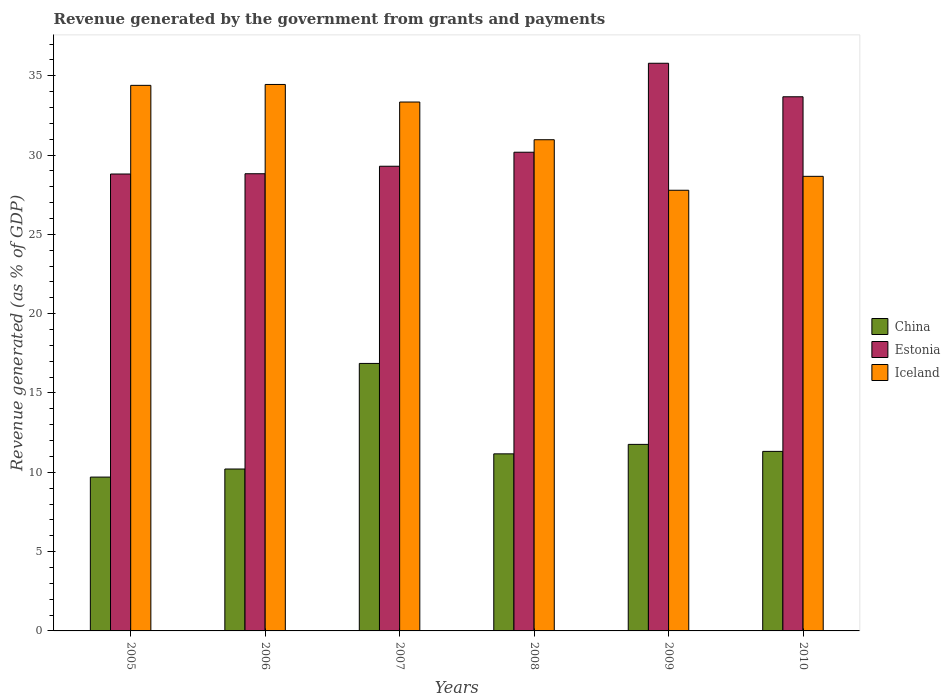How many different coloured bars are there?
Your response must be concise. 3. Are the number of bars on each tick of the X-axis equal?
Your answer should be very brief. Yes. How many bars are there on the 1st tick from the left?
Your answer should be very brief. 3. How many bars are there on the 5th tick from the right?
Offer a very short reply. 3. What is the revenue generated by the government in Iceland in 2010?
Give a very brief answer. 28.66. Across all years, what is the maximum revenue generated by the government in China?
Your answer should be very brief. 16.86. Across all years, what is the minimum revenue generated by the government in China?
Provide a short and direct response. 9.7. In which year was the revenue generated by the government in Estonia minimum?
Provide a succinct answer. 2005. What is the total revenue generated by the government in Iceland in the graph?
Offer a terse response. 189.6. What is the difference between the revenue generated by the government in China in 2006 and that in 2010?
Provide a succinct answer. -1.11. What is the difference between the revenue generated by the government in China in 2009 and the revenue generated by the government in Iceland in 2006?
Your answer should be very brief. -22.69. What is the average revenue generated by the government in Iceland per year?
Give a very brief answer. 31.6. In the year 2007, what is the difference between the revenue generated by the government in Iceland and revenue generated by the government in Estonia?
Give a very brief answer. 4.05. In how many years, is the revenue generated by the government in Estonia greater than 33 %?
Provide a short and direct response. 2. What is the ratio of the revenue generated by the government in Estonia in 2006 to that in 2009?
Offer a very short reply. 0.81. Is the revenue generated by the government in China in 2005 less than that in 2008?
Your answer should be very brief. Yes. What is the difference between the highest and the second highest revenue generated by the government in Iceland?
Your answer should be compact. 0.06. What is the difference between the highest and the lowest revenue generated by the government in China?
Offer a terse response. 7.17. Is the sum of the revenue generated by the government in Iceland in 2005 and 2009 greater than the maximum revenue generated by the government in China across all years?
Provide a short and direct response. Yes. What does the 2nd bar from the left in 2007 represents?
Your answer should be very brief. Estonia. What does the 2nd bar from the right in 2005 represents?
Make the answer very short. Estonia. How many bars are there?
Provide a succinct answer. 18. Are all the bars in the graph horizontal?
Make the answer very short. No. Where does the legend appear in the graph?
Your response must be concise. Center right. How are the legend labels stacked?
Provide a succinct answer. Vertical. What is the title of the graph?
Your answer should be compact. Revenue generated by the government from grants and payments. Does "Tuvalu" appear as one of the legend labels in the graph?
Provide a succinct answer. No. What is the label or title of the Y-axis?
Your answer should be very brief. Revenue generated (as % of GDP). What is the Revenue generated (as % of GDP) in China in 2005?
Your answer should be very brief. 9.7. What is the Revenue generated (as % of GDP) in Estonia in 2005?
Your answer should be very brief. 28.81. What is the Revenue generated (as % of GDP) in Iceland in 2005?
Make the answer very short. 34.4. What is the Revenue generated (as % of GDP) of China in 2006?
Offer a terse response. 10.21. What is the Revenue generated (as % of GDP) in Estonia in 2006?
Ensure brevity in your answer.  28.82. What is the Revenue generated (as % of GDP) in Iceland in 2006?
Ensure brevity in your answer.  34.45. What is the Revenue generated (as % of GDP) of China in 2007?
Your answer should be compact. 16.86. What is the Revenue generated (as % of GDP) of Estonia in 2007?
Offer a very short reply. 29.3. What is the Revenue generated (as % of GDP) in Iceland in 2007?
Your answer should be very brief. 33.34. What is the Revenue generated (as % of GDP) in China in 2008?
Your response must be concise. 11.16. What is the Revenue generated (as % of GDP) in Estonia in 2008?
Give a very brief answer. 30.18. What is the Revenue generated (as % of GDP) of Iceland in 2008?
Offer a terse response. 30.97. What is the Revenue generated (as % of GDP) in China in 2009?
Offer a very short reply. 11.76. What is the Revenue generated (as % of GDP) of Estonia in 2009?
Provide a short and direct response. 35.79. What is the Revenue generated (as % of GDP) of Iceland in 2009?
Provide a succinct answer. 27.78. What is the Revenue generated (as % of GDP) in China in 2010?
Your response must be concise. 11.32. What is the Revenue generated (as % of GDP) of Estonia in 2010?
Your answer should be compact. 33.68. What is the Revenue generated (as % of GDP) of Iceland in 2010?
Ensure brevity in your answer.  28.66. Across all years, what is the maximum Revenue generated (as % of GDP) in China?
Give a very brief answer. 16.86. Across all years, what is the maximum Revenue generated (as % of GDP) of Estonia?
Provide a short and direct response. 35.79. Across all years, what is the maximum Revenue generated (as % of GDP) of Iceland?
Keep it short and to the point. 34.45. Across all years, what is the minimum Revenue generated (as % of GDP) in China?
Provide a short and direct response. 9.7. Across all years, what is the minimum Revenue generated (as % of GDP) of Estonia?
Your answer should be very brief. 28.81. Across all years, what is the minimum Revenue generated (as % of GDP) in Iceland?
Your response must be concise. 27.78. What is the total Revenue generated (as % of GDP) of China in the graph?
Provide a succinct answer. 71.01. What is the total Revenue generated (as % of GDP) of Estonia in the graph?
Your answer should be very brief. 186.57. What is the total Revenue generated (as % of GDP) of Iceland in the graph?
Make the answer very short. 189.6. What is the difference between the Revenue generated (as % of GDP) in China in 2005 and that in 2006?
Make the answer very short. -0.51. What is the difference between the Revenue generated (as % of GDP) of Estonia in 2005 and that in 2006?
Ensure brevity in your answer.  -0.02. What is the difference between the Revenue generated (as % of GDP) of Iceland in 2005 and that in 2006?
Your response must be concise. -0.06. What is the difference between the Revenue generated (as % of GDP) in China in 2005 and that in 2007?
Offer a terse response. -7.17. What is the difference between the Revenue generated (as % of GDP) of Estonia in 2005 and that in 2007?
Your answer should be very brief. -0.49. What is the difference between the Revenue generated (as % of GDP) in Iceland in 2005 and that in 2007?
Give a very brief answer. 1.05. What is the difference between the Revenue generated (as % of GDP) of China in 2005 and that in 2008?
Ensure brevity in your answer.  -1.47. What is the difference between the Revenue generated (as % of GDP) of Estonia in 2005 and that in 2008?
Provide a short and direct response. -1.37. What is the difference between the Revenue generated (as % of GDP) in Iceland in 2005 and that in 2008?
Provide a succinct answer. 3.43. What is the difference between the Revenue generated (as % of GDP) in China in 2005 and that in 2009?
Make the answer very short. -2.06. What is the difference between the Revenue generated (as % of GDP) of Estonia in 2005 and that in 2009?
Give a very brief answer. -6.98. What is the difference between the Revenue generated (as % of GDP) of Iceland in 2005 and that in 2009?
Give a very brief answer. 6.61. What is the difference between the Revenue generated (as % of GDP) in China in 2005 and that in 2010?
Offer a very short reply. -1.62. What is the difference between the Revenue generated (as % of GDP) of Estonia in 2005 and that in 2010?
Your answer should be compact. -4.87. What is the difference between the Revenue generated (as % of GDP) in Iceland in 2005 and that in 2010?
Make the answer very short. 5.74. What is the difference between the Revenue generated (as % of GDP) of China in 2006 and that in 2007?
Provide a succinct answer. -6.66. What is the difference between the Revenue generated (as % of GDP) in Estonia in 2006 and that in 2007?
Ensure brevity in your answer.  -0.47. What is the difference between the Revenue generated (as % of GDP) of Iceland in 2006 and that in 2007?
Your response must be concise. 1.11. What is the difference between the Revenue generated (as % of GDP) in China in 2006 and that in 2008?
Provide a succinct answer. -0.96. What is the difference between the Revenue generated (as % of GDP) in Estonia in 2006 and that in 2008?
Your answer should be very brief. -1.36. What is the difference between the Revenue generated (as % of GDP) of Iceland in 2006 and that in 2008?
Provide a succinct answer. 3.48. What is the difference between the Revenue generated (as % of GDP) of China in 2006 and that in 2009?
Your answer should be compact. -1.55. What is the difference between the Revenue generated (as % of GDP) of Estonia in 2006 and that in 2009?
Provide a succinct answer. -6.97. What is the difference between the Revenue generated (as % of GDP) in Iceland in 2006 and that in 2009?
Give a very brief answer. 6.67. What is the difference between the Revenue generated (as % of GDP) in China in 2006 and that in 2010?
Make the answer very short. -1.11. What is the difference between the Revenue generated (as % of GDP) of Estonia in 2006 and that in 2010?
Give a very brief answer. -4.85. What is the difference between the Revenue generated (as % of GDP) of Iceland in 2006 and that in 2010?
Provide a short and direct response. 5.79. What is the difference between the Revenue generated (as % of GDP) in China in 2007 and that in 2008?
Offer a very short reply. 5.7. What is the difference between the Revenue generated (as % of GDP) in Estonia in 2007 and that in 2008?
Provide a short and direct response. -0.88. What is the difference between the Revenue generated (as % of GDP) of Iceland in 2007 and that in 2008?
Your answer should be compact. 2.38. What is the difference between the Revenue generated (as % of GDP) in China in 2007 and that in 2009?
Your response must be concise. 5.1. What is the difference between the Revenue generated (as % of GDP) of Estonia in 2007 and that in 2009?
Provide a succinct answer. -6.49. What is the difference between the Revenue generated (as % of GDP) in Iceland in 2007 and that in 2009?
Your answer should be very brief. 5.56. What is the difference between the Revenue generated (as % of GDP) in China in 2007 and that in 2010?
Offer a terse response. 5.54. What is the difference between the Revenue generated (as % of GDP) in Estonia in 2007 and that in 2010?
Your answer should be very brief. -4.38. What is the difference between the Revenue generated (as % of GDP) in Iceland in 2007 and that in 2010?
Ensure brevity in your answer.  4.69. What is the difference between the Revenue generated (as % of GDP) of China in 2008 and that in 2009?
Ensure brevity in your answer.  -0.6. What is the difference between the Revenue generated (as % of GDP) in Estonia in 2008 and that in 2009?
Offer a very short reply. -5.61. What is the difference between the Revenue generated (as % of GDP) in Iceland in 2008 and that in 2009?
Provide a succinct answer. 3.19. What is the difference between the Revenue generated (as % of GDP) of China in 2008 and that in 2010?
Your answer should be very brief. -0.16. What is the difference between the Revenue generated (as % of GDP) in Estonia in 2008 and that in 2010?
Ensure brevity in your answer.  -3.5. What is the difference between the Revenue generated (as % of GDP) of Iceland in 2008 and that in 2010?
Make the answer very short. 2.31. What is the difference between the Revenue generated (as % of GDP) in China in 2009 and that in 2010?
Make the answer very short. 0.44. What is the difference between the Revenue generated (as % of GDP) of Estonia in 2009 and that in 2010?
Offer a very short reply. 2.11. What is the difference between the Revenue generated (as % of GDP) of Iceland in 2009 and that in 2010?
Provide a succinct answer. -0.88. What is the difference between the Revenue generated (as % of GDP) in China in 2005 and the Revenue generated (as % of GDP) in Estonia in 2006?
Make the answer very short. -19.12. What is the difference between the Revenue generated (as % of GDP) of China in 2005 and the Revenue generated (as % of GDP) of Iceland in 2006?
Provide a short and direct response. -24.75. What is the difference between the Revenue generated (as % of GDP) of Estonia in 2005 and the Revenue generated (as % of GDP) of Iceland in 2006?
Your answer should be very brief. -5.65. What is the difference between the Revenue generated (as % of GDP) of China in 2005 and the Revenue generated (as % of GDP) of Estonia in 2007?
Your answer should be compact. -19.6. What is the difference between the Revenue generated (as % of GDP) of China in 2005 and the Revenue generated (as % of GDP) of Iceland in 2007?
Provide a short and direct response. -23.65. What is the difference between the Revenue generated (as % of GDP) of Estonia in 2005 and the Revenue generated (as % of GDP) of Iceland in 2007?
Offer a terse response. -4.54. What is the difference between the Revenue generated (as % of GDP) of China in 2005 and the Revenue generated (as % of GDP) of Estonia in 2008?
Offer a very short reply. -20.48. What is the difference between the Revenue generated (as % of GDP) of China in 2005 and the Revenue generated (as % of GDP) of Iceland in 2008?
Your response must be concise. -21.27. What is the difference between the Revenue generated (as % of GDP) of Estonia in 2005 and the Revenue generated (as % of GDP) of Iceland in 2008?
Give a very brief answer. -2.16. What is the difference between the Revenue generated (as % of GDP) of China in 2005 and the Revenue generated (as % of GDP) of Estonia in 2009?
Your answer should be compact. -26.09. What is the difference between the Revenue generated (as % of GDP) of China in 2005 and the Revenue generated (as % of GDP) of Iceland in 2009?
Keep it short and to the point. -18.08. What is the difference between the Revenue generated (as % of GDP) of Estonia in 2005 and the Revenue generated (as % of GDP) of Iceland in 2009?
Offer a very short reply. 1.02. What is the difference between the Revenue generated (as % of GDP) of China in 2005 and the Revenue generated (as % of GDP) of Estonia in 2010?
Offer a terse response. -23.98. What is the difference between the Revenue generated (as % of GDP) of China in 2005 and the Revenue generated (as % of GDP) of Iceland in 2010?
Ensure brevity in your answer.  -18.96. What is the difference between the Revenue generated (as % of GDP) in Estonia in 2005 and the Revenue generated (as % of GDP) in Iceland in 2010?
Make the answer very short. 0.15. What is the difference between the Revenue generated (as % of GDP) of China in 2006 and the Revenue generated (as % of GDP) of Estonia in 2007?
Ensure brevity in your answer.  -19.09. What is the difference between the Revenue generated (as % of GDP) of China in 2006 and the Revenue generated (as % of GDP) of Iceland in 2007?
Ensure brevity in your answer.  -23.14. What is the difference between the Revenue generated (as % of GDP) in Estonia in 2006 and the Revenue generated (as % of GDP) in Iceland in 2007?
Make the answer very short. -4.52. What is the difference between the Revenue generated (as % of GDP) of China in 2006 and the Revenue generated (as % of GDP) of Estonia in 2008?
Offer a terse response. -19.97. What is the difference between the Revenue generated (as % of GDP) in China in 2006 and the Revenue generated (as % of GDP) in Iceland in 2008?
Provide a short and direct response. -20.76. What is the difference between the Revenue generated (as % of GDP) of Estonia in 2006 and the Revenue generated (as % of GDP) of Iceland in 2008?
Your response must be concise. -2.14. What is the difference between the Revenue generated (as % of GDP) in China in 2006 and the Revenue generated (as % of GDP) in Estonia in 2009?
Provide a succinct answer. -25.58. What is the difference between the Revenue generated (as % of GDP) in China in 2006 and the Revenue generated (as % of GDP) in Iceland in 2009?
Your answer should be very brief. -17.57. What is the difference between the Revenue generated (as % of GDP) in Estonia in 2006 and the Revenue generated (as % of GDP) in Iceland in 2009?
Offer a very short reply. 1.04. What is the difference between the Revenue generated (as % of GDP) in China in 2006 and the Revenue generated (as % of GDP) in Estonia in 2010?
Your response must be concise. -23.47. What is the difference between the Revenue generated (as % of GDP) in China in 2006 and the Revenue generated (as % of GDP) in Iceland in 2010?
Provide a short and direct response. -18.45. What is the difference between the Revenue generated (as % of GDP) of Estonia in 2006 and the Revenue generated (as % of GDP) of Iceland in 2010?
Your response must be concise. 0.16. What is the difference between the Revenue generated (as % of GDP) in China in 2007 and the Revenue generated (as % of GDP) in Estonia in 2008?
Ensure brevity in your answer.  -13.32. What is the difference between the Revenue generated (as % of GDP) in China in 2007 and the Revenue generated (as % of GDP) in Iceland in 2008?
Your answer should be compact. -14.1. What is the difference between the Revenue generated (as % of GDP) of Estonia in 2007 and the Revenue generated (as % of GDP) of Iceland in 2008?
Provide a short and direct response. -1.67. What is the difference between the Revenue generated (as % of GDP) of China in 2007 and the Revenue generated (as % of GDP) of Estonia in 2009?
Offer a terse response. -18.92. What is the difference between the Revenue generated (as % of GDP) in China in 2007 and the Revenue generated (as % of GDP) in Iceland in 2009?
Offer a very short reply. -10.92. What is the difference between the Revenue generated (as % of GDP) in Estonia in 2007 and the Revenue generated (as % of GDP) in Iceland in 2009?
Make the answer very short. 1.51. What is the difference between the Revenue generated (as % of GDP) in China in 2007 and the Revenue generated (as % of GDP) in Estonia in 2010?
Offer a terse response. -16.81. What is the difference between the Revenue generated (as % of GDP) of China in 2007 and the Revenue generated (as % of GDP) of Iceland in 2010?
Offer a very short reply. -11.8. What is the difference between the Revenue generated (as % of GDP) in Estonia in 2007 and the Revenue generated (as % of GDP) in Iceland in 2010?
Keep it short and to the point. 0.64. What is the difference between the Revenue generated (as % of GDP) of China in 2008 and the Revenue generated (as % of GDP) of Estonia in 2009?
Your answer should be very brief. -24.62. What is the difference between the Revenue generated (as % of GDP) of China in 2008 and the Revenue generated (as % of GDP) of Iceland in 2009?
Your answer should be very brief. -16.62. What is the difference between the Revenue generated (as % of GDP) in Estonia in 2008 and the Revenue generated (as % of GDP) in Iceland in 2009?
Your answer should be very brief. 2.4. What is the difference between the Revenue generated (as % of GDP) of China in 2008 and the Revenue generated (as % of GDP) of Estonia in 2010?
Provide a succinct answer. -22.51. What is the difference between the Revenue generated (as % of GDP) of China in 2008 and the Revenue generated (as % of GDP) of Iceland in 2010?
Provide a succinct answer. -17.5. What is the difference between the Revenue generated (as % of GDP) of Estonia in 2008 and the Revenue generated (as % of GDP) of Iceland in 2010?
Your response must be concise. 1.52. What is the difference between the Revenue generated (as % of GDP) in China in 2009 and the Revenue generated (as % of GDP) in Estonia in 2010?
Give a very brief answer. -21.92. What is the difference between the Revenue generated (as % of GDP) of China in 2009 and the Revenue generated (as % of GDP) of Iceland in 2010?
Ensure brevity in your answer.  -16.9. What is the difference between the Revenue generated (as % of GDP) of Estonia in 2009 and the Revenue generated (as % of GDP) of Iceland in 2010?
Offer a very short reply. 7.13. What is the average Revenue generated (as % of GDP) of China per year?
Your answer should be compact. 11.84. What is the average Revenue generated (as % of GDP) of Estonia per year?
Make the answer very short. 31.09. What is the average Revenue generated (as % of GDP) of Iceland per year?
Provide a short and direct response. 31.6. In the year 2005, what is the difference between the Revenue generated (as % of GDP) of China and Revenue generated (as % of GDP) of Estonia?
Provide a succinct answer. -19.11. In the year 2005, what is the difference between the Revenue generated (as % of GDP) of China and Revenue generated (as % of GDP) of Iceland?
Make the answer very short. -24.7. In the year 2005, what is the difference between the Revenue generated (as % of GDP) of Estonia and Revenue generated (as % of GDP) of Iceland?
Your response must be concise. -5.59. In the year 2006, what is the difference between the Revenue generated (as % of GDP) in China and Revenue generated (as % of GDP) in Estonia?
Your answer should be compact. -18.62. In the year 2006, what is the difference between the Revenue generated (as % of GDP) of China and Revenue generated (as % of GDP) of Iceland?
Your response must be concise. -24.24. In the year 2006, what is the difference between the Revenue generated (as % of GDP) in Estonia and Revenue generated (as % of GDP) in Iceland?
Offer a very short reply. -5.63. In the year 2007, what is the difference between the Revenue generated (as % of GDP) of China and Revenue generated (as % of GDP) of Estonia?
Provide a short and direct response. -12.43. In the year 2007, what is the difference between the Revenue generated (as % of GDP) in China and Revenue generated (as % of GDP) in Iceland?
Your answer should be very brief. -16.48. In the year 2007, what is the difference between the Revenue generated (as % of GDP) of Estonia and Revenue generated (as % of GDP) of Iceland?
Your answer should be compact. -4.05. In the year 2008, what is the difference between the Revenue generated (as % of GDP) of China and Revenue generated (as % of GDP) of Estonia?
Keep it short and to the point. -19.02. In the year 2008, what is the difference between the Revenue generated (as % of GDP) in China and Revenue generated (as % of GDP) in Iceland?
Offer a very short reply. -19.8. In the year 2008, what is the difference between the Revenue generated (as % of GDP) in Estonia and Revenue generated (as % of GDP) in Iceland?
Give a very brief answer. -0.79. In the year 2009, what is the difference between the Revenue generated (as % of GDP) of China and Revenue generated (as % of GDP) of Estonia?
Give a very brief answer. -24.03. In the year 2009, what is the difference between the Revenue generated (as % of GDP) of China and Revenue generated (as % of GDP) of Iceland?
Give a very brief answer. -16.02. In the year 2009, what is the difference between the Revenue generated (as % of GDP) in Estonia and Revenue generated (as % of GDP) in Iceland?
Offer a terse response. 8.01. In the year 2010, what is the difference between the Revenue generated (as % of GDP) of China and Revenue generated (as % of GDP) of Estonia?
Ensure brevity in your answer.  -22.36. In the year 2010, what is the difference between the Revenue generated (as % of GDP) of China and Revenue generated (as % of GDP) of Iceland?
Provide a succinct answer. -17.34. In the year 2010, what is the difference between the Revenue generated (as % of GDP) of Estonia and Revenue generated (as % of GDP) of Iceland?
Your response must be concise. 5.02. What is the ratio of the Revenue generated (as % of GDP) in China in 2005 to that in 2006?
Give a very brief answer. 0.95. What is the ratio of the Revenue generated (as % of GDP) of China in 2005 to that in 2007?
Provide a succinct answer. 0.58. What is the ratio of the Revenue generated (as % of GDP) of Estonia in 2005 to that in 2007?
Ensure brevity in your answer.  0.98. What is the ratio of the Revenue generated (as % of GDP) in Iceland in 2005 to that in 2007?
Provide a succinct answer. 1.03. What is the ratio of the Revenue generated (as % of GDP) of China in 2005 to that in 2008?
Provide a short and direct response. 0.87. What is the ratio of the Revenue generated (as % of GDP) of Estonia in 2005 to that in 2008?
Offer a very short reply. 0.95. What is the ratio of the Revenue generated (as % of GDP) in Iceland in 2005 to that in 2008?
Provide a succinct answer. 1.11. What is the ratio of the Revenue generated (as % of GDP) in China in 2005 to that in 2009?
Your answer should be compact. 0.82. What is the ratio of the Revenue generated (as % of GDP) of Estonia in 2005 to that in 2009?
Keep it short and to the point. 0.8. What is the ratio of the Revenue generated (as % of GDP) in Iceland in 2005 to that in 2009?
Your response must be concise. 1.24. What is the ratio of the Revenue generated (as % of GDP) of China in 2005 to that in 2010?
Provide a short and direct response. 0.86. What is the ratio of the Revenue generated (as % of GDP) in Estonia in 2005 to that in 2010?
Your response must be concise. 0.86. What is the ratio of the Revenue generated (as % of GDP) in Iceland in 2005 to that in 2010?
Make the answer very short. 1.2. What is the ratio of the Revenue generated (as % of GDP) of China in 2006 to that in 2007?
Offer a terse response. 0.61. What is the ratio of the Revenue generated (as % of GDP) in Estonia in 2006 to that in 2007?
Your answer should be compact. 0.98. What is the ratio of the Revenue generated (as % of GDP) of Iceland in 2006 to that in 2007?
Your answer should be compact. 1.03. What is the ratio of the Revenue generated (as % of GDP) in China in 2006 to that in 2008?
Offer a very short reply. 0.91. What is the ratio of the Revenue generated (as % of GDP) of Estonia in 2006 to that in 2008?
Your answer should be compact. 0.96. What is the ratio of the Revenue generated (as % of GDP) in Iceland in 2006 to that in 2008?
Keep it short and to the point. 1.11. What is the ratio of the Revenue generated (as % of GDP) of China in 2006 to that in 2009?
Provide a succinct answer. 0.87. What is the ratio of the Revenue generated (as % of GDP) of Estonia in 2006 to that in 2009?
Offer a terse response. 0.81. What is the ratio of the Revenue generated (as % of GDP) in Iceland in 2006 to that in 2009?
Ensure brevity in your answer.  1.24. What is the ratio of the Revenue generated (as % of GDP) in China in 2006 to that in 2010?
Ensure brevity in your answer.  0.9. What is the ratio of the Revenue generated (as % of GDP) in Estonia in 2006 to that in 2010?
Give a very brief answer. 0.86. What is the ratio of the Revenue generated (as % of GDP) of Iceland in 2006 to that in 2010?
Keep it short and to the point. 1.2. What is the ratio of the Revenue generated (as % of GDP) in China in 2007 to that in 2008?
Provide a short and direct response. 1.51. What is the ratio of the Revenue generated (as % of GDP) in Estonia in 2007 to that in 2008?
Provide a short and direct response. 0.97. What is the ratio of the Revenue generated (as % of GDP) in Iceland in 2007 to that in 2008?
Provide a succinct answer. 1.08. What is the ratio of the Revenue generated (as % of GDP) of China in 2007 to that in 2009?
Ensure brevity in your answer.  1.43. What is the ratio of the Revenue generated (as % of GDP) in Estonia in 2007 to that in 2009?
Give a very brief answer. 0.82. What is the ratio of the Revenue generated (as % of GDP) of Iceland in 2007 to that in 2009?
Keep it short and to the point. 1.2. What is the ratio of the Revenue generated (as % of GDP) of China in 2007 to that in 2010?
Your response must be concise. 1.49. What is the ratio of the Revenue generated (as % of GDP) of Estonia in 2007 to that in 2010?
Your answer should be compact. 0.87. What is the ratio of the Revenue generated (as % of GDP) of Iceland in 2007 to that in 2010?
Make the answer very short. 1.16. What is the ratio of the Revenue generated (as % of GDP) of China in 2008 to that in 2009?
Offer a very short reply. 0.95. What is the ratio of the Revenue generated (as % of GDP) in Estonia in 2008 to that in 2009?
Make the answer very short. 0.84. What is the ratio of the Revenue generated (as % of GDP) in Iceland in 2008 to that in 2009?
Give a very brief answer. 1.11. What is the ratio of the Revenue generated (as % of GDP) in China in 2008 to that in 2010?
Offer a very short reply. 0.99. What is the ratio of the Revenue generated (as % of GDP) in Estonia in 2008 to that in 2010?
Provide a succinct answer. 0.9. What is the ratio of the Revenue generated (as % of GDP) in Iceland in 2008 to that in 2010?
Offer a terse response. 1.08. What is the ratio of the Revenue generated (as % of GDP) of China in 2009 to that in 2010?
Provide a short and direct response. 1.04. What is the ratio of the Revenue generated (as % of GDP) of Estonia in 2009 to that in 2010?
Give a very brief answer. 1.06. What is the ratio of the Revenue generated (as % of GDP) of Iceland in 2009 to that in 2010?
Make the answer very short. 0.97. What is the difference between the highest and the second highest Revenue generated (as % of GDP) of China?
Your answer should be very brief. 5.1. What is the difference between the highest and the second highest Revenue generated (as % of GDP) of Estonia?
Your answer should be compact. 2.11. What is the difference between the highest and the second highest Revenue generated (as % of GDP) of Iceland?
Make the answer very short. 0.06. What is the difference between the highest and the lowest Revenue generated (as % of GDP) of China?
Keep it short and to the point. 7.17. What is the difference between the highest and the lowest Revenue generated (as % of GDP) in Estonia?
Give a very brief answer. 6.98. What is the difference between the highest and the lowest Revenue generated (as % of GDP) of Iceland?
Your response must be concise. 6.67. 